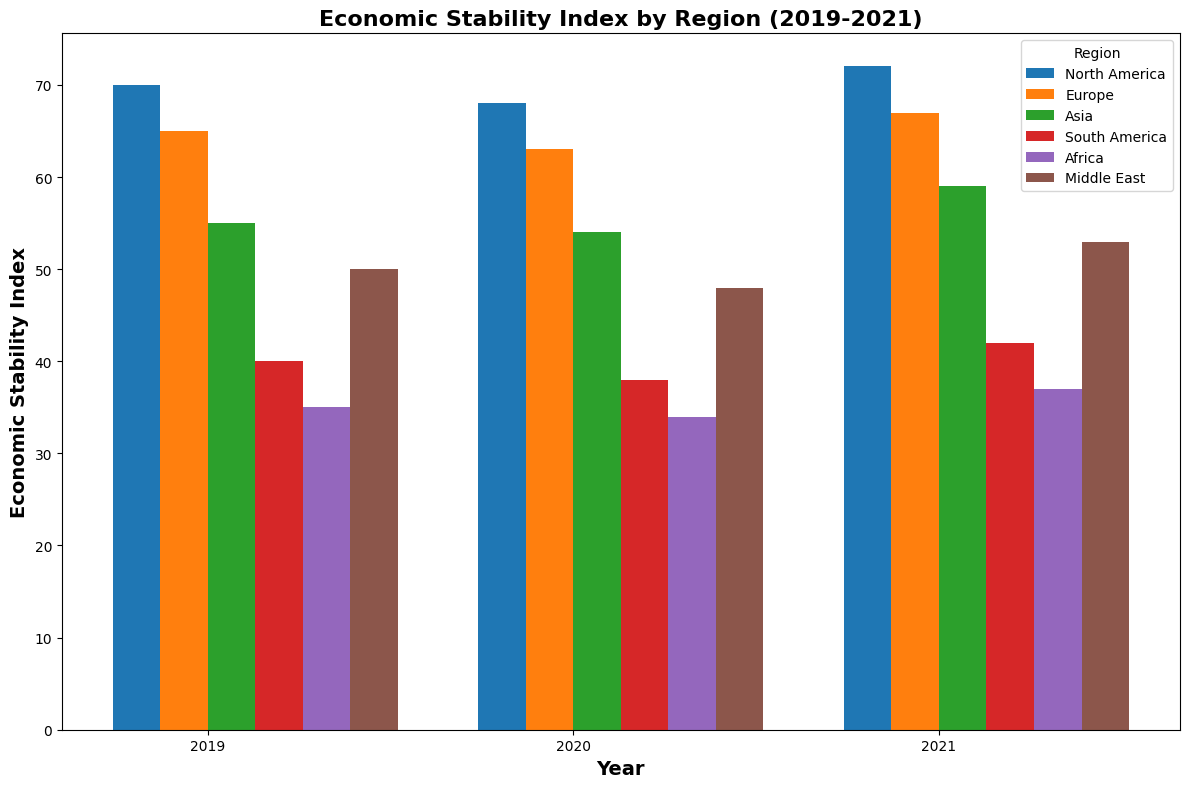What region has the highest Economic Stability Index in 2021? Visually, we can observe that the tallest bar in 2021 belongs to North America. North America's bar is the highest among all regions in that year.
Answer: North America How did the Economic Stability Index change for Asia from 2019 to 2021? To find the change, we need to compare the bar heights for Asia in 2019 and 2021. In 2019, the index was 55, and in 2021, it was 59. So, the difference is 59 - 55.
Answer: Increased by 4 Which region has the lowest Economic Stability Index in 2020 and what is its value? By comparing the heights of the bars for all regions in 2020, the shortest bar corresponds to Africa. The value of Africa's index in 2020 is 34.
Answer: Africa, 34 What’s the average Economic Stability Index for Europe over the years shown? Add the indices for Europe for 2019, 2020, and 2021 (65 + 63 + 67) and then divide by 3. 65 + 63 + 67 = 195; 195 / 3 = 65
Answer: 65 Which region showed the greatest improvement from 2019 to 2021? We need to calculate the change for each region from 2019 to 2021 and compare them. For North America: 72 - 70 = 2, Europe: 67 - 65 = 2, Asia: 59 - 55 = 4, South America: 42 - 40 = 2, Africa: 37 - 35 = 2, Middle East: 53 - 50 = 3. The largest change is for Asia with an increase of 4.
Answer: Asia Compare the Economic Stability Index of Europe and North America in 2020. Which region had a higher index? We need to see the heights of the bars for Europe and North America in 2020. Europe had an index of 63 while North America had an index of 68. North America’s index is higher.
Answer: North America What is the average Economic Stability Index for all regions in 2020? Sum the indices for each region in 2020: North America 68, Europe 63, Asia 54, South America 38, Africa 34, Middle East 48. Total = 305; Average = 305 / 6 = 50.83
Answer: 50.83 What is the difference in the Economic Stability Index between South America and Africa in 2019? Find and subtract the indices of South America and Africa in 2019. South America's index is 40, and Africa's index is 35. 40 - 35 = 5
Answer: 5 Which year had the highest overall Economic Stability Index for all regions combined? Sum the indices for all regions for each year. For 2019: 70 + 65 + 55 + 40 + 35 + 50 = 315, For 2020: 68 + 63 + 54 + 38 + 34 + 48 = 305, For 2021: 72 + 67 + 59 + 42 + 37 + 53 = 330. The year with the highest combined index is 2021.
Answer: 2021 